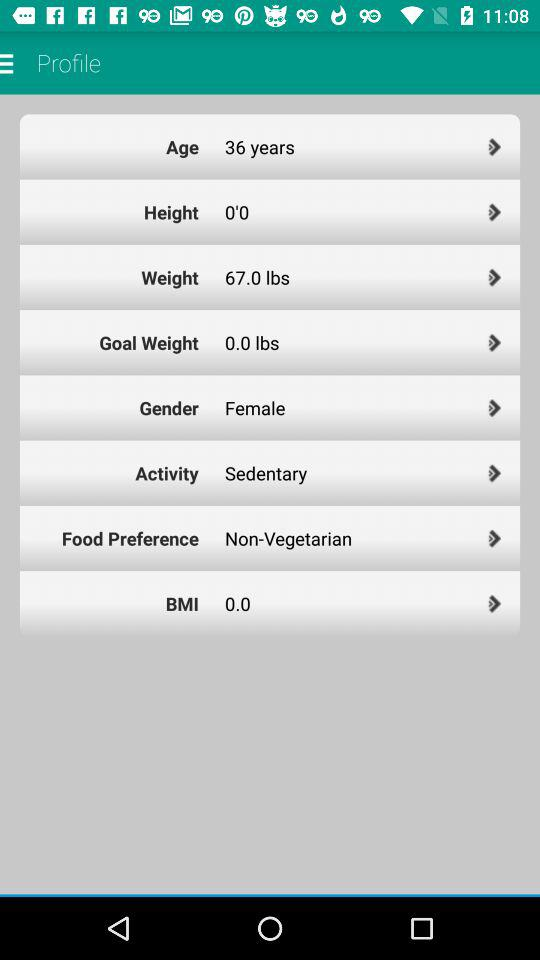What is the gender of the user?
Answer the question using a single word or phrase. Female 